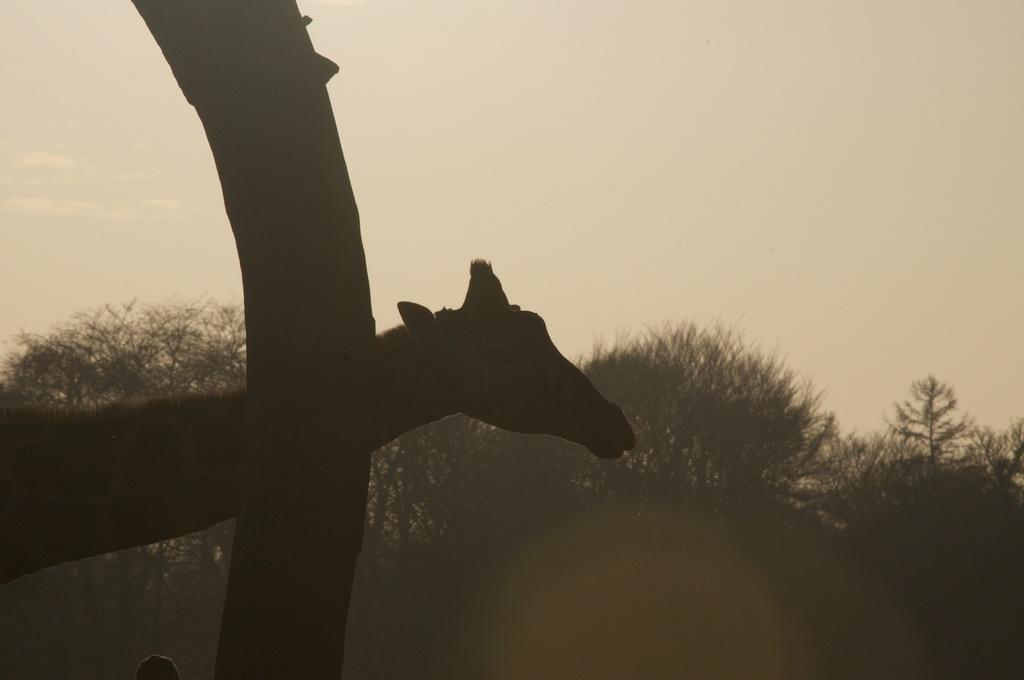What animal is located on the left side of the image? There is a camel on the left side of the image. Are there any other camels visible in the image? There may be another camel in the image. What can be seen in the background of the image? There are trees in the background of the image. What type of advice is the camel giving to the plants in the image? There are no plants present in the image, and the camel is not giving any advice. 